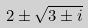Convert formula to latex. <formula><loc_0><loc_0><loc_500><loc_500>2 \pm \sqrt { 3 \pm i }</formula> 